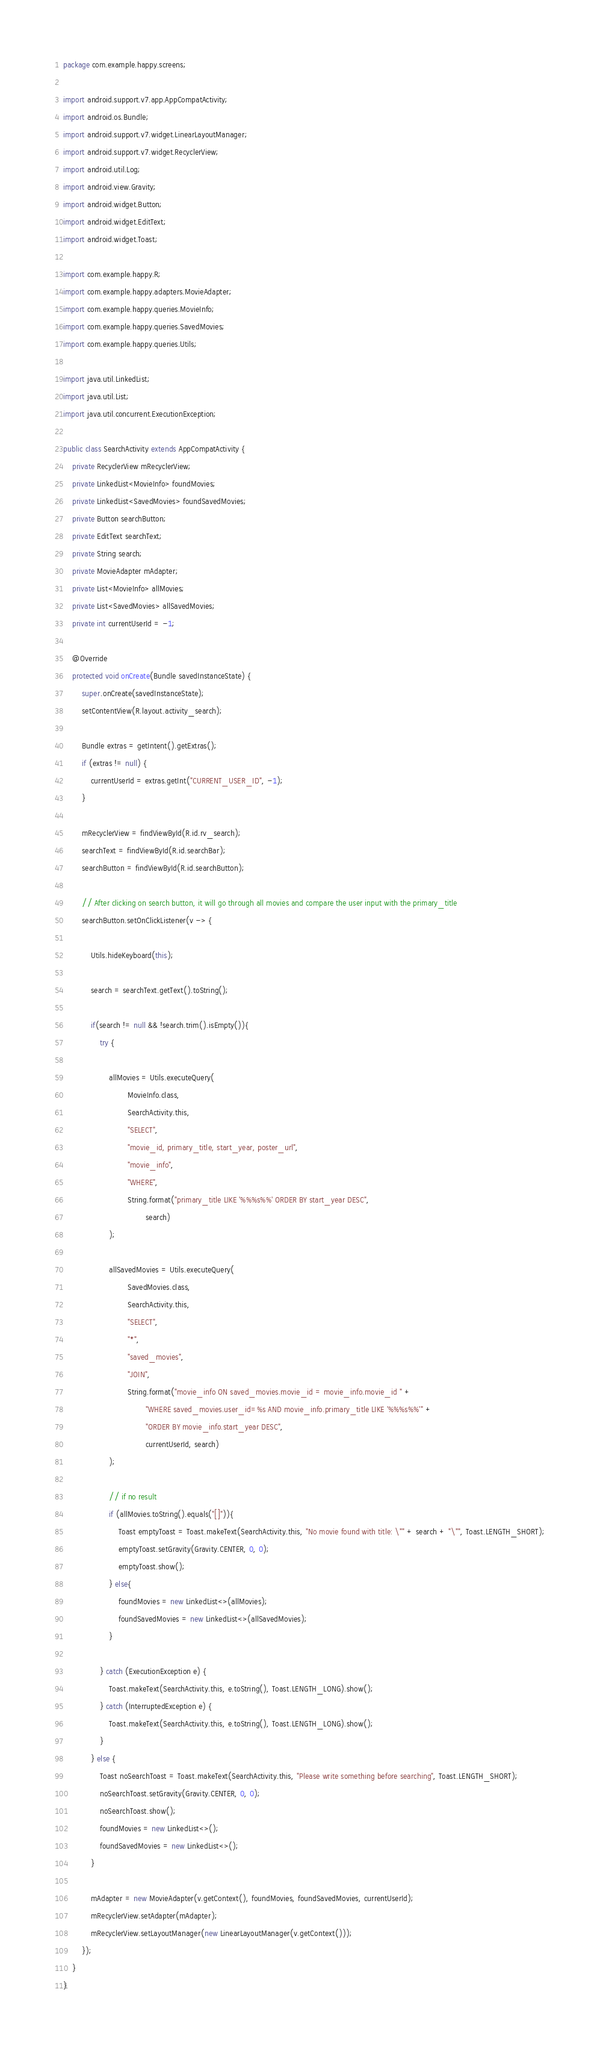Convert code to text. <code><loc_0><loc_0><loc_500><loc_500><_Java_>package com.example.happy.screens;

import android.support.v7.app.AppCompatActivity;
import android.os.Bundle;
import android.support.v7.widget.LinearLayoutManager;
import android.support.v7.widget.RecyclerView;
import android.util.Log;
import android.view.Gravity;
import android.widget.Button;
import android.widget.EditText;
import android.widget.Toast;

import com.example.happy.R;
import com.example.happy.adapters.MovieAdapter;
import com.example.happy.queries.MovieInfo;
import com.example.happy.queries.SavedMovies;
import com.example.happy.queries.Utils;

import java.util.LinkedList;
import java.util.List;
import java.util.concurrent.ExecutionException;

public class SearchActivity extends AppCompatActivity {
    private RecyclerView mRecyclerView;
    private LinkedList<MovieInfo> foundMovies;
    private LinkedList<SavedMovies> foundSavedMovies;
    private Button searchButton;
    private EditText searchText;
    private String search;
    private MovieAdapter mAdapter;
    private List<MovieInfo> allMovies;
    private List<SavedMovies> allSavedMovies;
    private int currentUserId = -1;

    @Override
    protected void onCreate(Bundle savedInstanceState) {
        super.onCreate(savedInstanceState);
        setContentView(R.layout.activity_search);

        Bundle extras = getIntent().getExtras();
        if (extras != null) {
            currentUserId = extras.getInt("CURRENT_USER_ID", -1);
        }

        mRecyclerView = findViewById(R.id.rv_search);
        searchText = findViewById(R.id.searchBar);
        searchButton = findViewById(R.id.searchButton);

        // After clicking on search button, it will go through all movies and compare the user input with the primary_title
        searchButton.setOnClickListener(v -> {

            Utils.hideKeyboard(this);

            search = searchText.getText().toString();

            if(search != null && !search.trim().isEmpty()){
                try {

                    allMovies = Utils.executeQuery(
                            MovieInfo.class,
                            SearchActivity.this,
                            "SELECT",
                            "movie_id, primary_title, start_year, poster_url",
                            "movie_info",
                            "WHERE",
                            String.format("primary_title LIKE '%%%s%%' ORDER BY start_year DESC",
                                    search)
                    );

                    allSavedMovies = Utils.executeQuery(
                            SavedMovies.class,
                            SearchActivity.this,
                            "SELECT",
                            "*",
                            "saved_movies",
                            "JOIN",
                            String.format("movie_info ON saved_movies.movie_id = movie_info.movie_id " +
                                    "WHERE saved_movies.user_id=%s AND movie_info.primary_title LIKE '%%%s%%'" +
                                    "ORDER BY movie_info.start_year DESC",
                                    currentUserId, search)
                    );

                    // if no result
                    if (allMovies.toString().equals("[]")){
                        Toast emptyToast = Toast.makeText(SearchActivity.this, "No movie found with title: \"" + search + "\"", Toast.LENGTH_SHORT);
                        emptyToast.setGravity(Gravity.CENTER, 0, 0);
                        emptyToast.show();
                    } else{
                        foundMovies = new LinkedList<>(allMovies);
                        foundSavedMovies = new LinkedList<>(allSavedMovies);
                    }

                } catch (ExecutionException e) {
                    Toast.makeText(SearchActivity.this, e.toString(), Toast.LENGTH_LONG).show();
                } catch (InterruptedException e) {
                    Toast.makeText(SearchActivity.this, e.toString(), Toast.LENGTH_LONG).show();
                }
            } else {
                Toast noSearchToast = Toast.makeText(SearchActivity.this, "Please write something before searching", Toast.LENGTH_SHORT);
                noSearchToast.setGravity(Gravity.CENTER, 0, 0);
                noSearchToast.show();
                foundMovies = new LinkedList<>();
                foundSavedMovies = new LinkedList<>();
            }

            mAdapter = new MovieAdapter(v.getContext(), foundMovies, foundSavedMovies, currentUserId);
            mRecyclerView.setAdapter(mAdapter);
            mRecyclerView.setLayoutManager(new LinearLayoutManager(v.getContext()));
        });
    }
}
</code> 